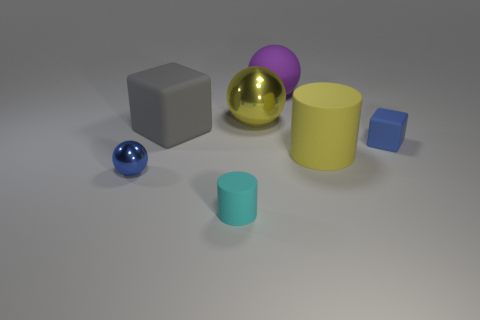Add 1 small red balls. How many objects exist? 8 Subtract all balls. How many objects are left? 4 Add 7 blue spheres. How many blue spheres are left? 8 Add 7 tiny matte things. How many tiny matte things exist? 9 Subtract 1 blue cubes. How many objects are left? 6 Subtract all large gray objects. Subtract all matte cylinders. How many objects are left? 4 